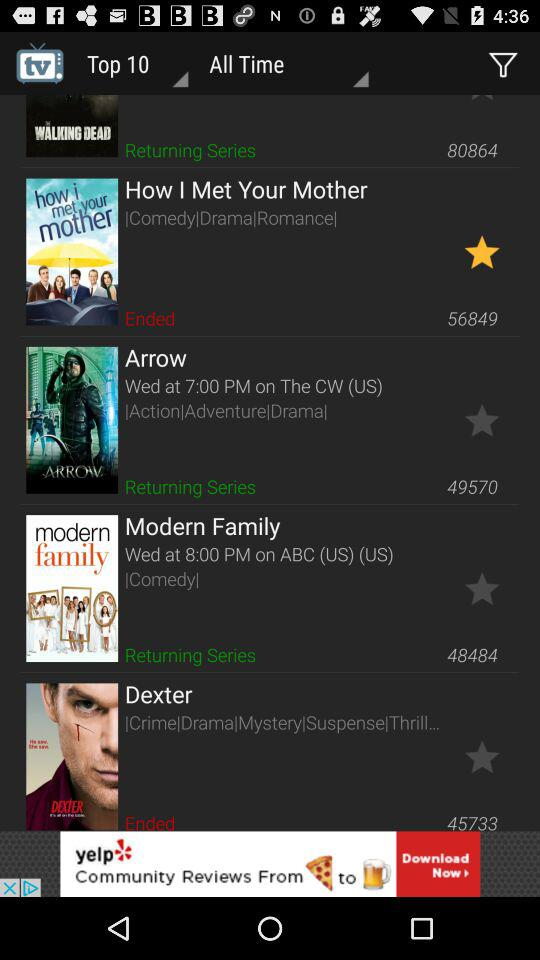What is the time of "Arrow" series? The time of "Arrow" series is 7:00 PM. 